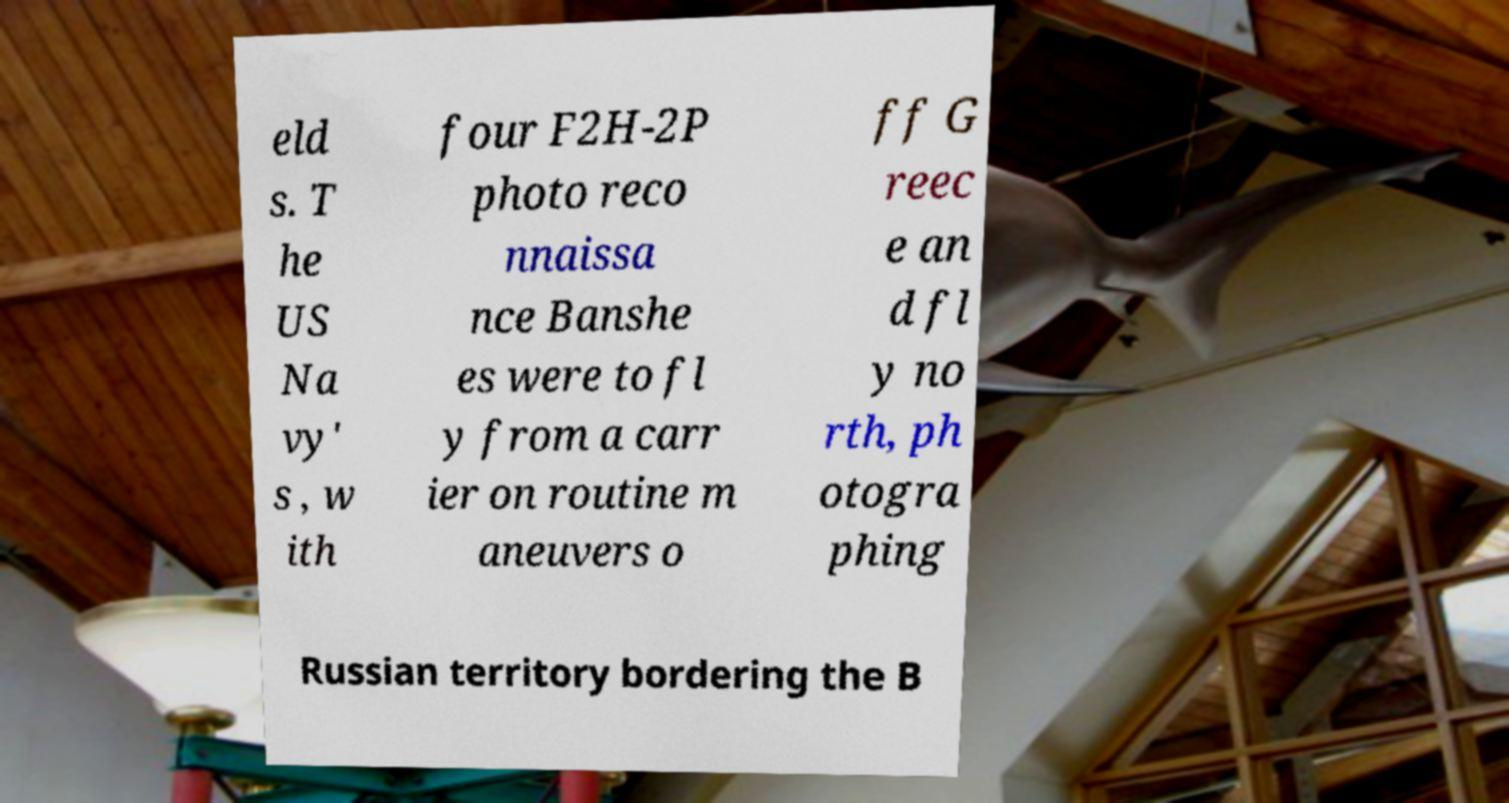Can you accurately transcribe the text from the provided image for me? eld s. T he US Na vy' s , w ith four F2H-2P photo reco nnaissa nce Banshe es were to fl y from a carr ier on routine m aneuvers o ff G reec e an d fl y no rth, ph otogra phing Russian territory bordering the B 